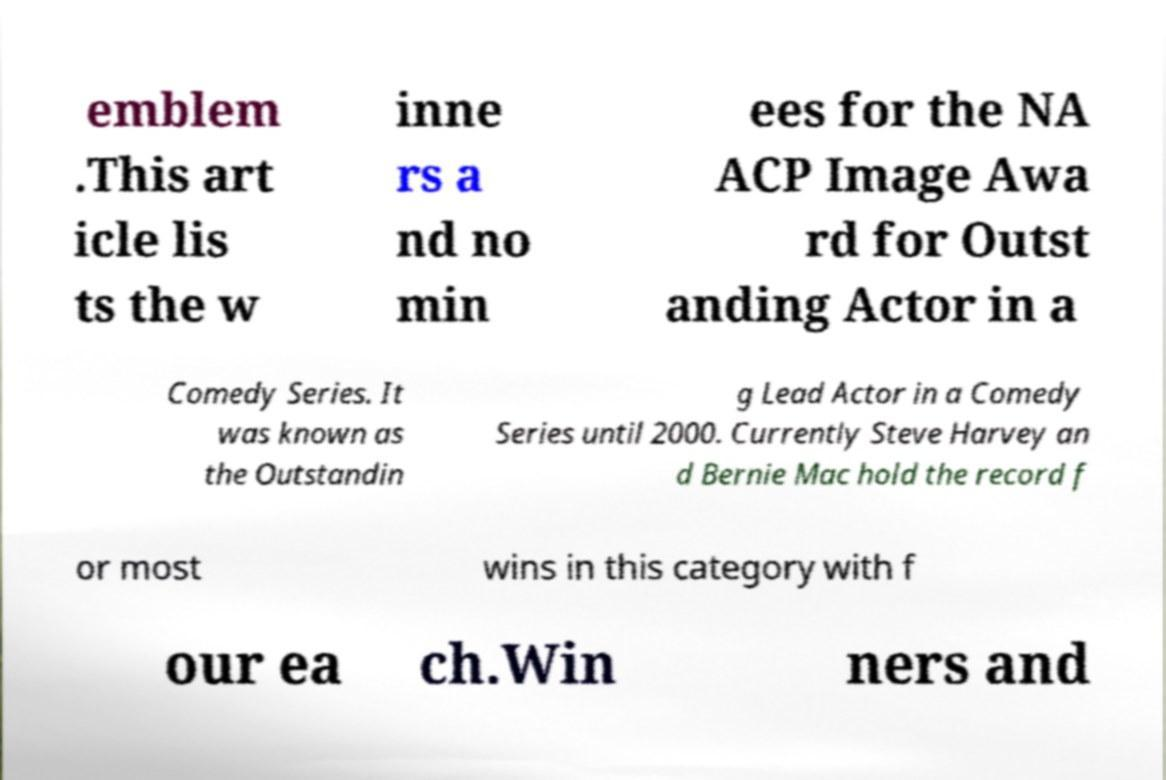Can you read and provide the text displayed in the image?This photo seems to have some interesting text. Can you extract and type it out for me? emblem .This art icle lis ts the w inne rs a nd no min ees for the NA ACP Image Awa rd for Outst anding Actor in a Comedy Series. It was known as the Outstandin g Lead Actor in a Comedy Series until 2000. Currently Steve Harvey an d Bernie Mac hold the record f or most wins in this category with f our ea ch.Win ners and 